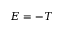Convert formula to latex. <formula><loc_0><loc_0><loc_500><loc_500>E = - T</formula> 